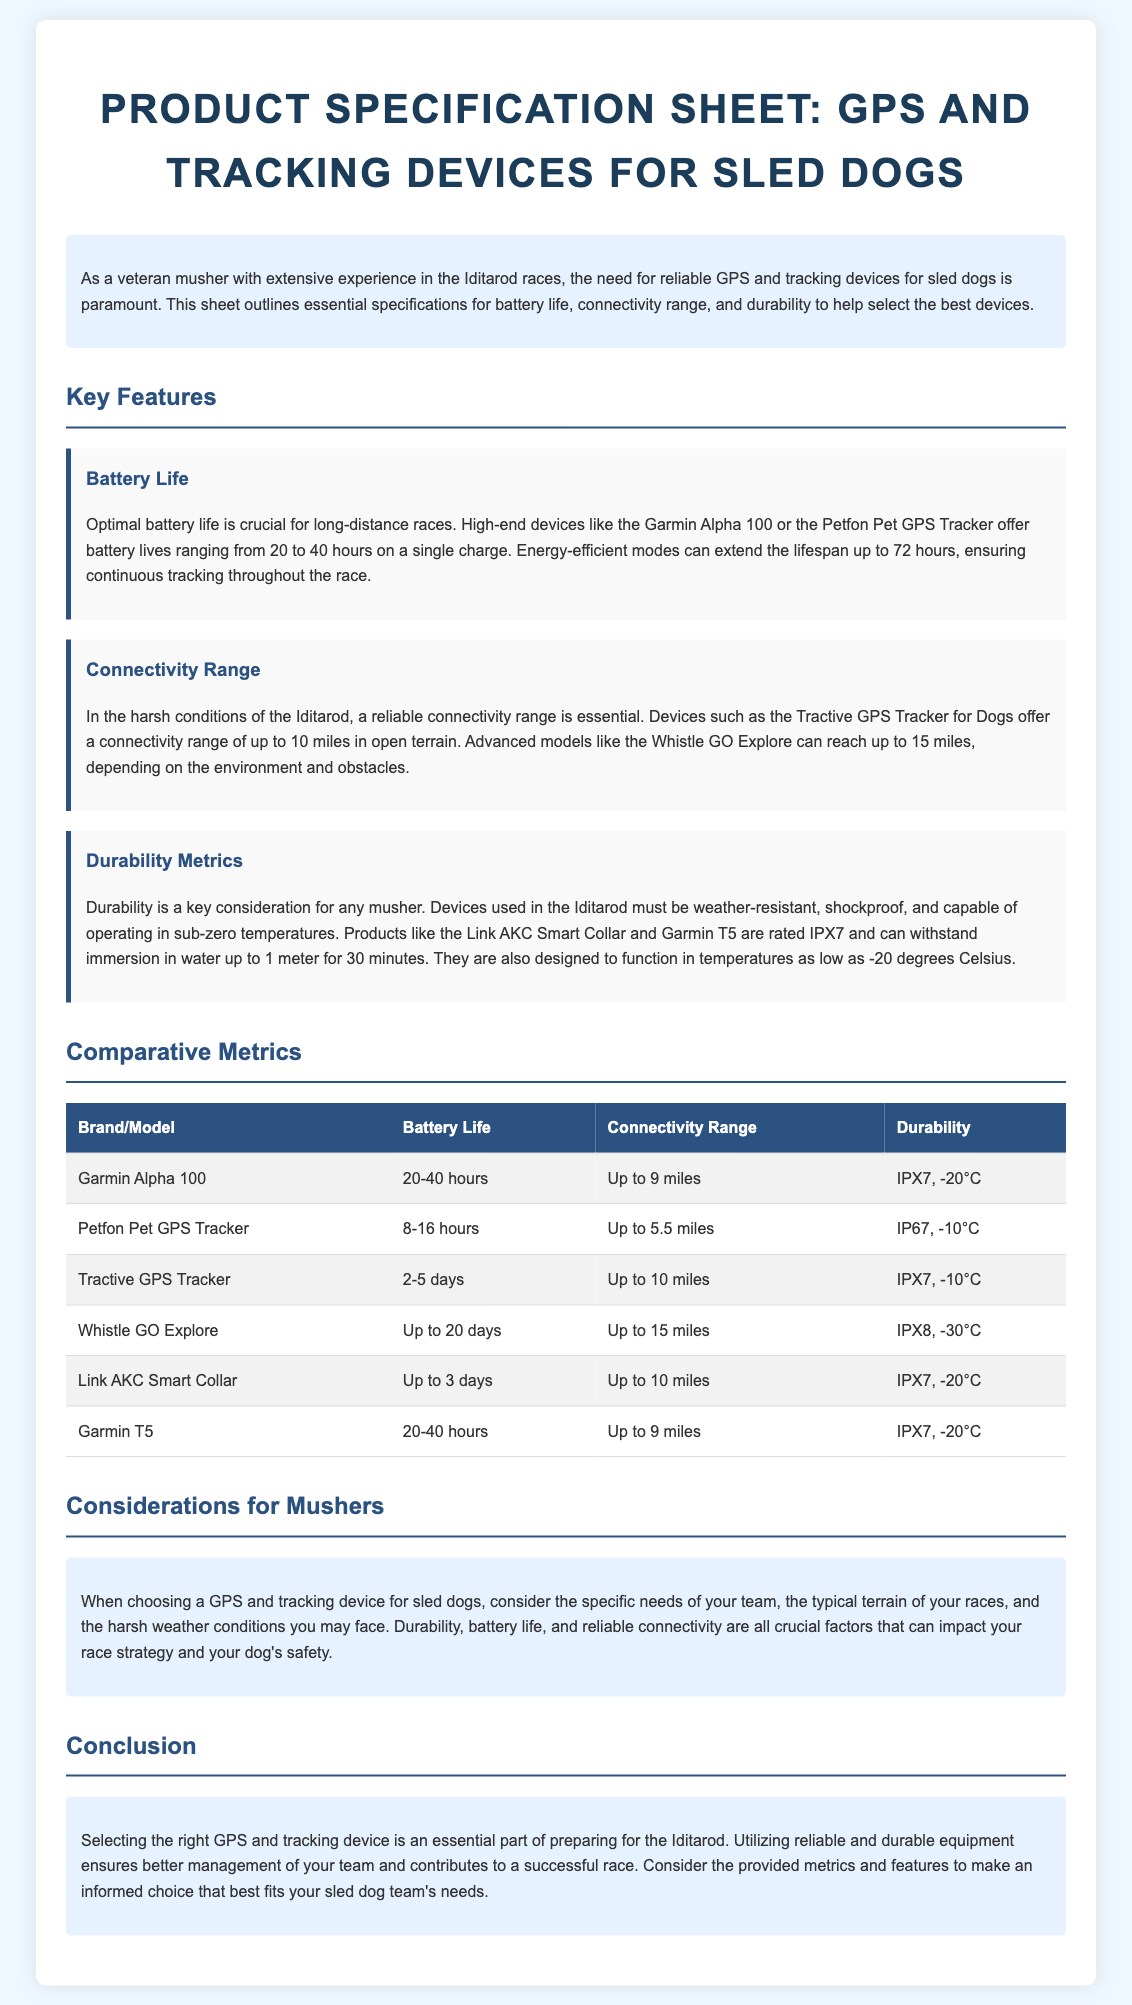What is the battery life of the Garmin Alpha 100? The Garmin Alpha 100 has a battery life ranging from 20 to 40 hours on a single charge.
Answer: 20-40 hours What is the connectivity range of the Whistle GO Explore? The Whistle GO Explore has a connectivity range of up to 15 miles.
Answer: Up to 15 miles Which device is rated for sub-zero temperatures of -30°C? The Whistle GO Explore is rated to function in temperatures as low as -30 degrees Celsius.
Answer: Whistle GO Explore What does IPX7 rating indicate? The IPX7 rating indicates that the device is weather-resistant and can withstand immersion in water up to 1 meter for 30 minutes.
Answer: Weather-resistant Which device offers optimal battery life extension through energy-efficient modes? The document mentions that both the Garmin Alpha 100 and the Petfon Pet GPS Tracker have energy-efficient modes to extend battery life.
Answer: Garmin Alpha 100, Petfon Pet GPS Tracker What is the typical temperature limit for devices rated IP67? Devices rated IP67 can operate in temperatures as low as -10 degrees Celsius.
Answer: -10°C What are the two main factors listed for selecting a GPS and tracking device? The key factors are battery life and reliable connectivity.
Answer: Battery life, reliable connectivity What is the title of the document? The title of the document describes it as a product specification sheet specifically for GPS and tracking devices for sled dogs.
Answer: Product Specification Sheet: GPS and Tracking Devices for Sled Dogs 